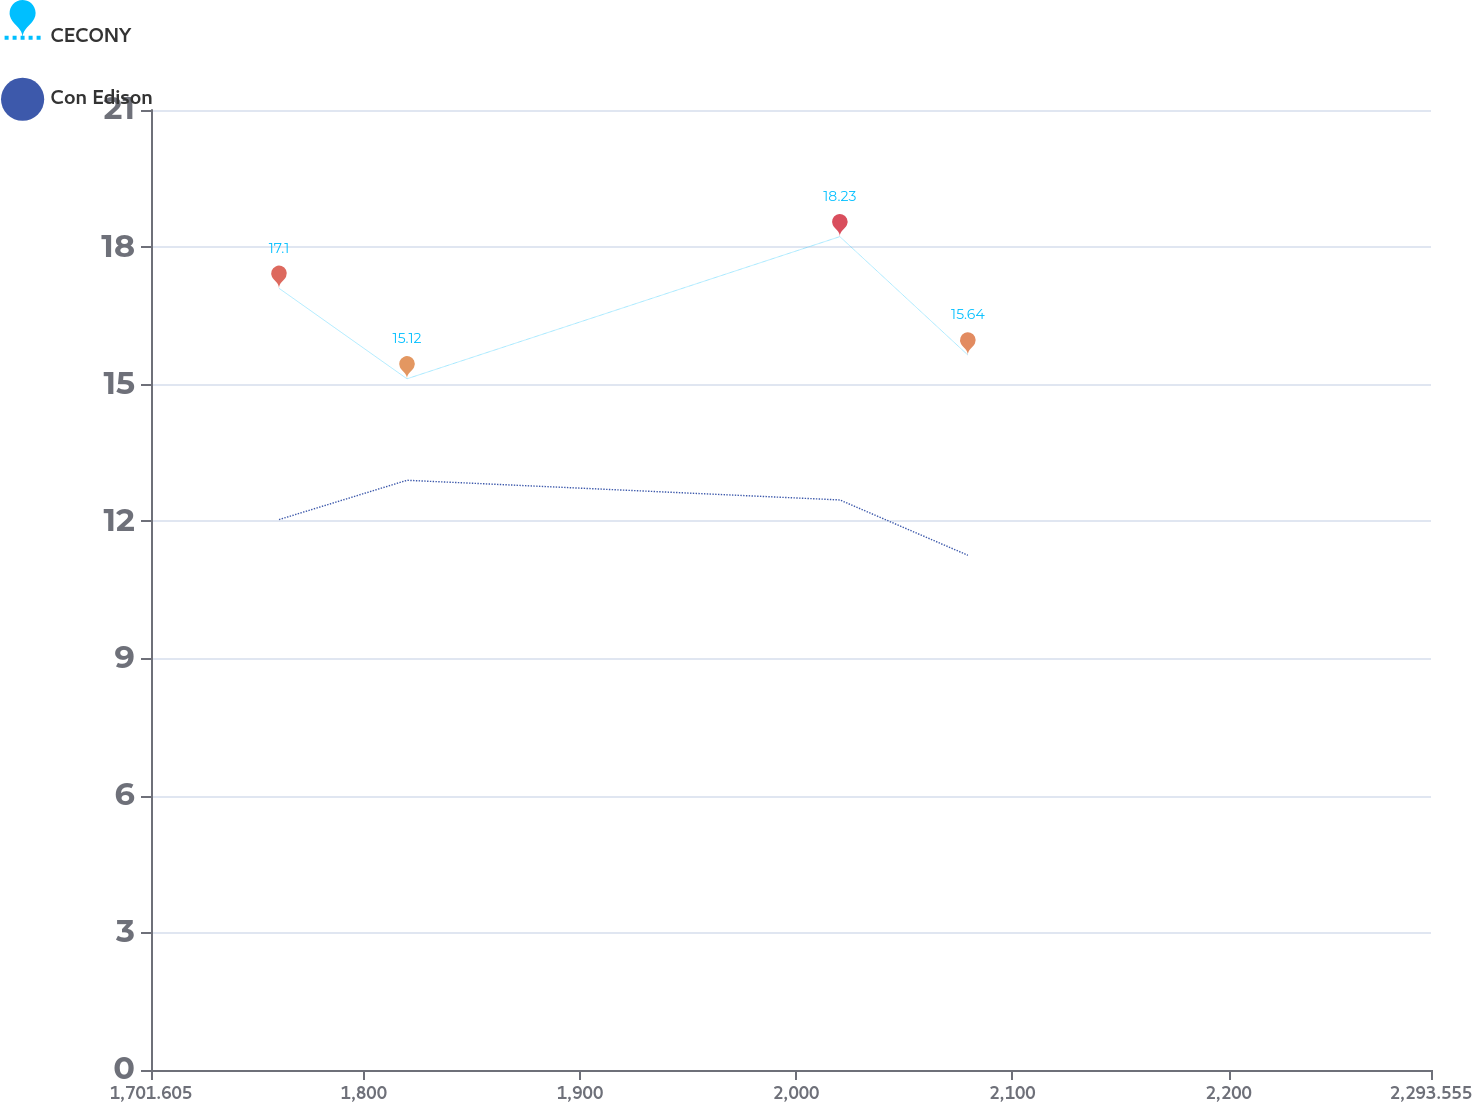Convert chart. <chart><loc_0><loc_0><loc_500><loc_500><line_chart><ecel><fcel>CECONY<fcel>Con Edison<nl><fcel>1760.8<fcel>17.1<fcel>12.04<nl><fcel>1819.99<fcel>15.12<fcel>12.9<nl><fcel>2020.17<fcel>18.23<fcel>12.47<nl><fcel>2079.37<fcel>15.64<fcel>11.26<nl><fcel>2352.75<fcel>13.06<fcel>7.97<nl></chart> 